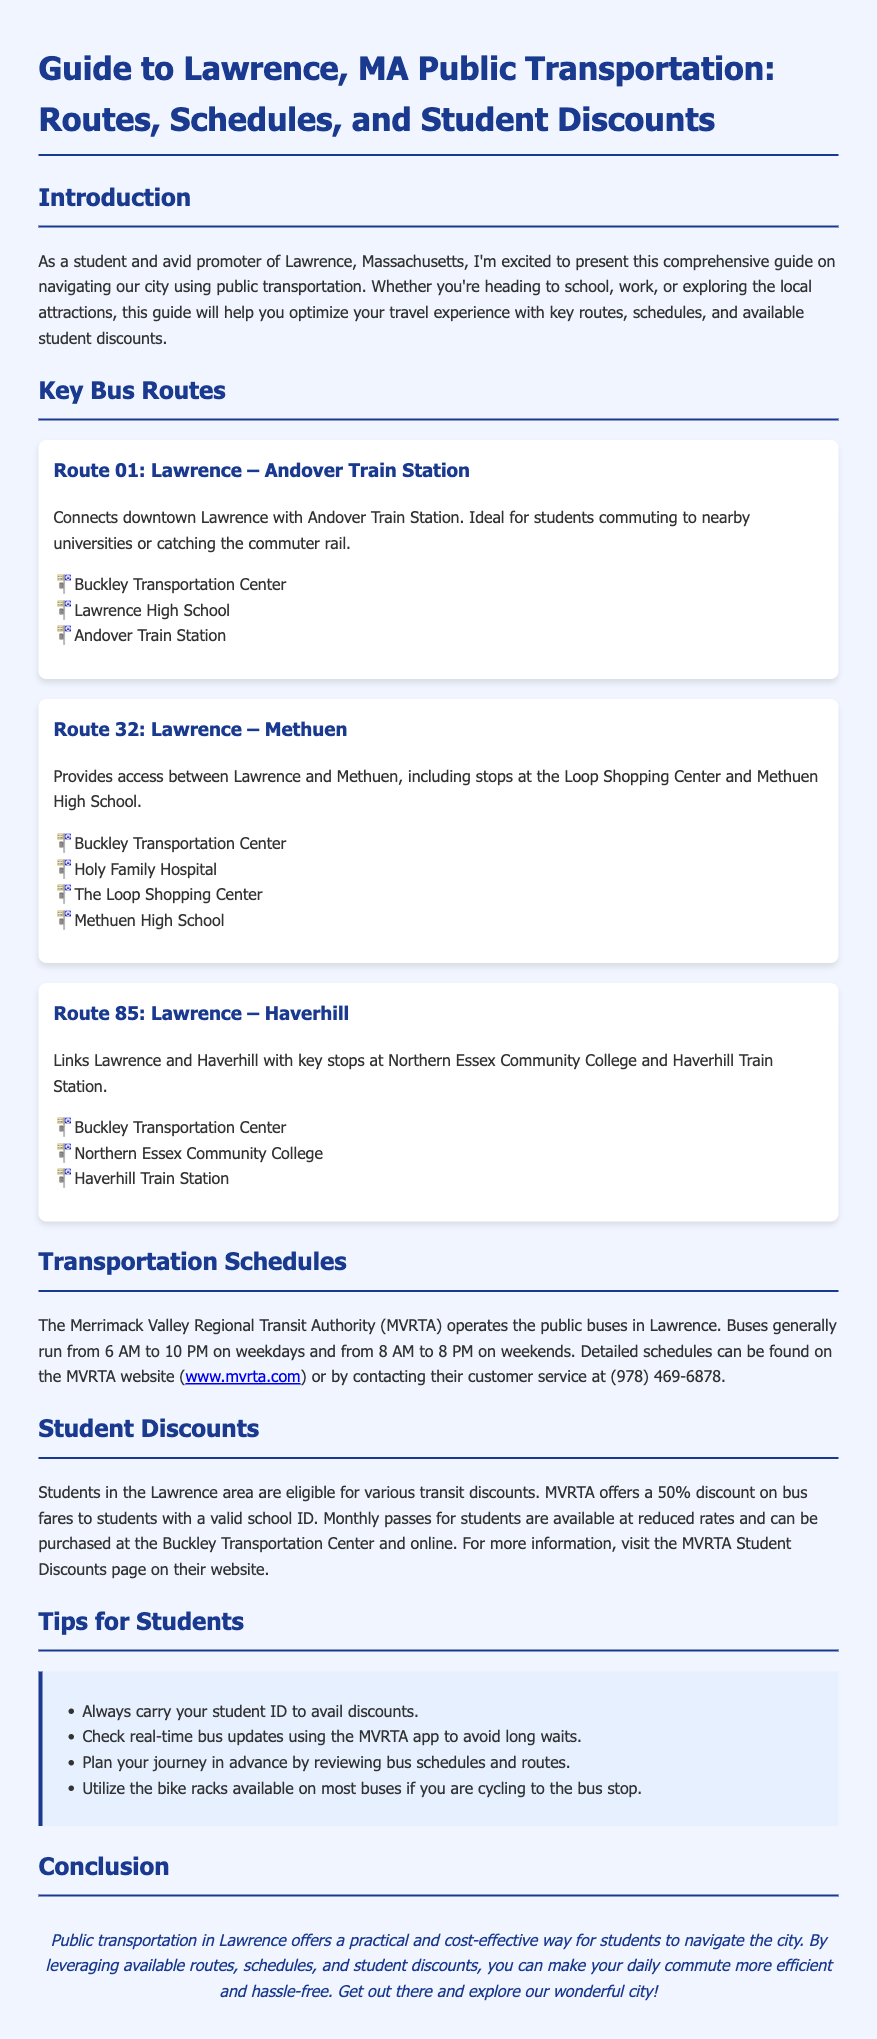What is the title of the guide? The title is the heading of the document and provides a clear indication of its content.
Answer: Guide to Lawrence, MA Public Transportation: Routes, Schedules, and Student Discounts What is the first key stop on Route 01? The first key stop is mentioned in the list under Route 01, indicating where the route begins.
Answer: Buckley Transportation Center What discount does MVRTA offer to students? The discount is specified under the Student Discounts section, highlighting the proportion of fare reduction for students.
Answer: 50% What time do buses typically start running on weekdays? The common starting time for buses on weekdays is noted in the Transportation Schedules section.
Answer: 6 AM Which route connects Lawrence and Methuen? This route is explicitly mentioned in the Key Bus Routes section, detailing the coverage area.
Answer: Route 32 What should students always carry to avail discounts? This is suggested in the Tips for Students section as necessary for obtaining student discounts on transportation.
Answer: Student ID How can students check real-time bus updates? The method to check bus updates is detailed in the Tips for Students section as a recommendation for planning.
Answer: MVRTA app What are the operational hours for buses on weekends? The operational hours for weekends are stated in the Transportation Schedules section.
Answer: 8 AM to 8 PM Where can students purchase monthly passes? The locations where monthly passes can be bought are mentioned in the Student Discounts section.
Answer: Buckley Transportation Center and online 